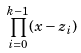<formula> <loc_0><loc_0><loc_500><loc_500>\prod _ { i = 0 } ^ { k - 1 } ( x - z _ { i } )</formula> 